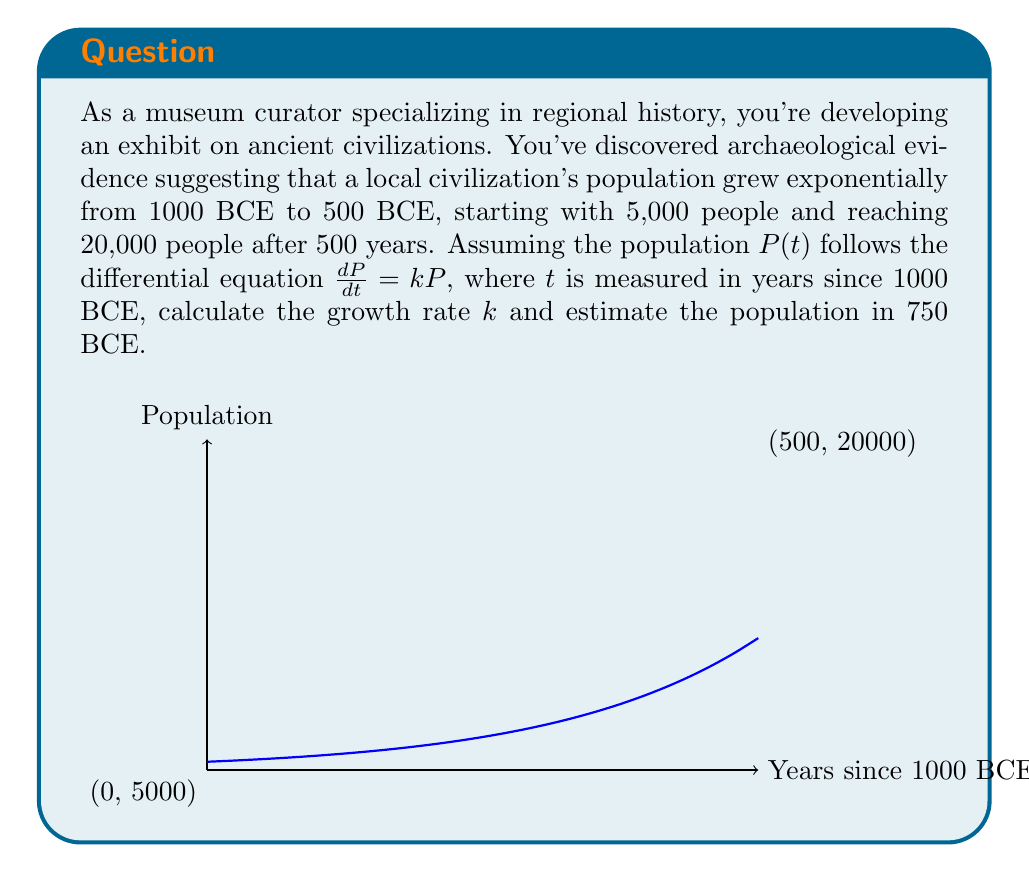Give your solution to this math problem. Let's approach this step-by-step:

1) The differential equation for exponential growth is:

   $$\frac{dP}{dt} = kP$$

2) The solution to this equation is:

   $$P(t) = P_0e^{kt}$$

   where $P_0$ is the initial population.

3) We know that:
   - At $t=0$ (1000 BCE), $P(0) = 5,000$
   - At $t=500$ (500 BCE), $P(500) = 20,000$

4) Let's use these conditions to find $k$:

   $$20,000 = 5,000e^{500k}$$

5) Dividing both sides by 5,000:

   $$4 = e^{500k}$$

6) Taking the natural log of both sides:

   $$\ln(4) = 500k$$

7) Solving for $k$:

   $$k = \frac{\ln(4)}{500} \approx 0.00277$$

8) Now that we have $k$, we can estimate the population in 750 BCE, which is 250 years after our starting point:

   $$P(250) = 5,000e^{0.00277 * 250} \approx 10,954$$
Answer: $k \approx 0.00277$; Population in 750 BCE $\approx 10,954$ 